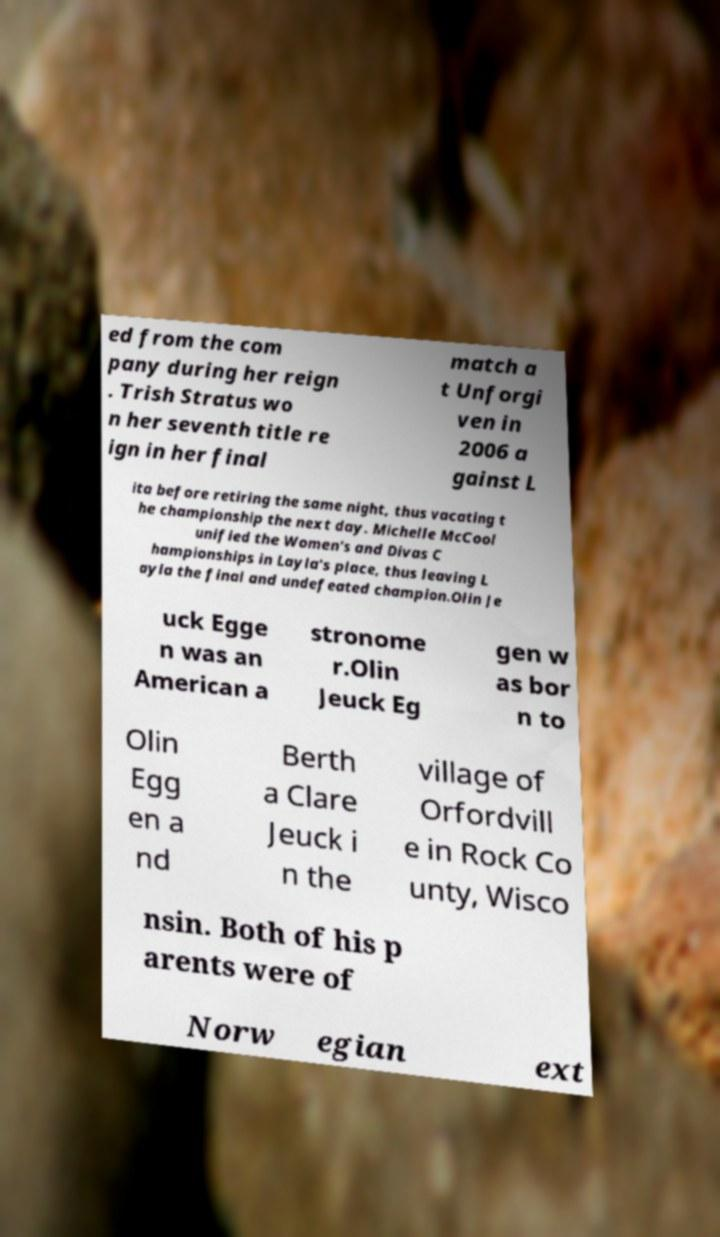Please read and relay the text visible in this image. What does it say? ed from the com pany during her reign . Trish Stratus wo n her seventh title re ign in her final match a t Unforgi ven in 2006 a gainst L ita before retiring the same night, thus vacating t he championship the next day. Michelle McCool unified the Women's and Divas C hampionships in Layla's place, thus leaving L ayla the final and undefeated champion.Olin Je uck Egge n was an American a stronome r.Olin Jeuck Eg gen w as bor n to Olin Egg en a nd Berth a Clare Jeuck i n the village of Orfordvill e in Rock Co unty, Wisco nsin. Both of his p arents were of Norw egian ext 